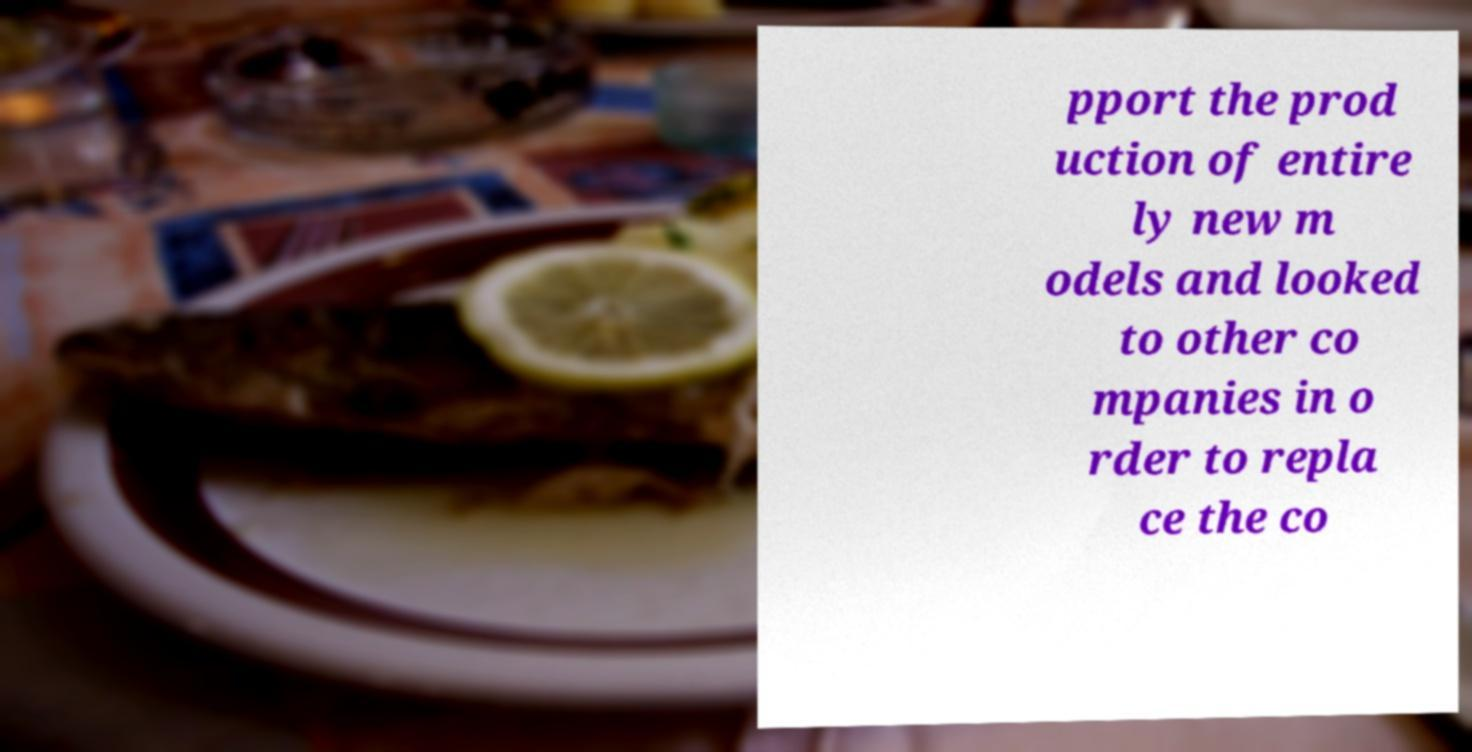Can you accurately transcribe the text from the provided image for me? pport the prod uction of entire ly new m odels and looked to other co mpanies in o rder to repla ce the co 